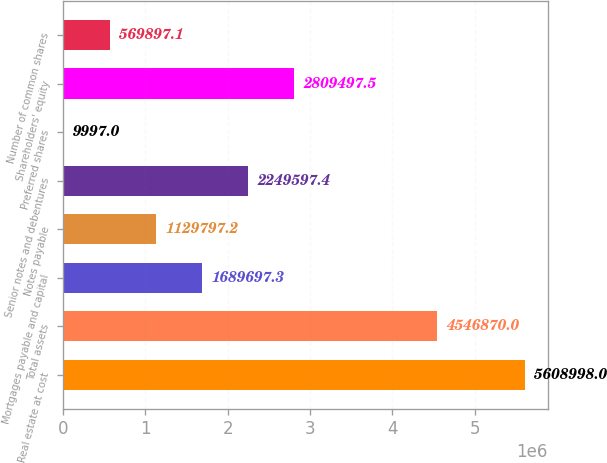Convert chart to OTSL. <chart><loc_0><loc_0><loc_500><loc_500><bar_chart><fcel>Real estate at cost<fcel>Total assets<fcel>Mortgages payable and capital<fcel>Notes payable<fcel>Senior notes and debentures<fcel>Preferred shares<fcel>Shareholders' equity<fcel>Number of common shares<nl><fcel>5.609e+06<fcel>4.54687e+06<fcel>1.6897e+06<fcel>1.1298e+06<fcel>2.2496e+06<fcel>9997<fcel>2.8095e+06<fcel>569897<nl></chart> 